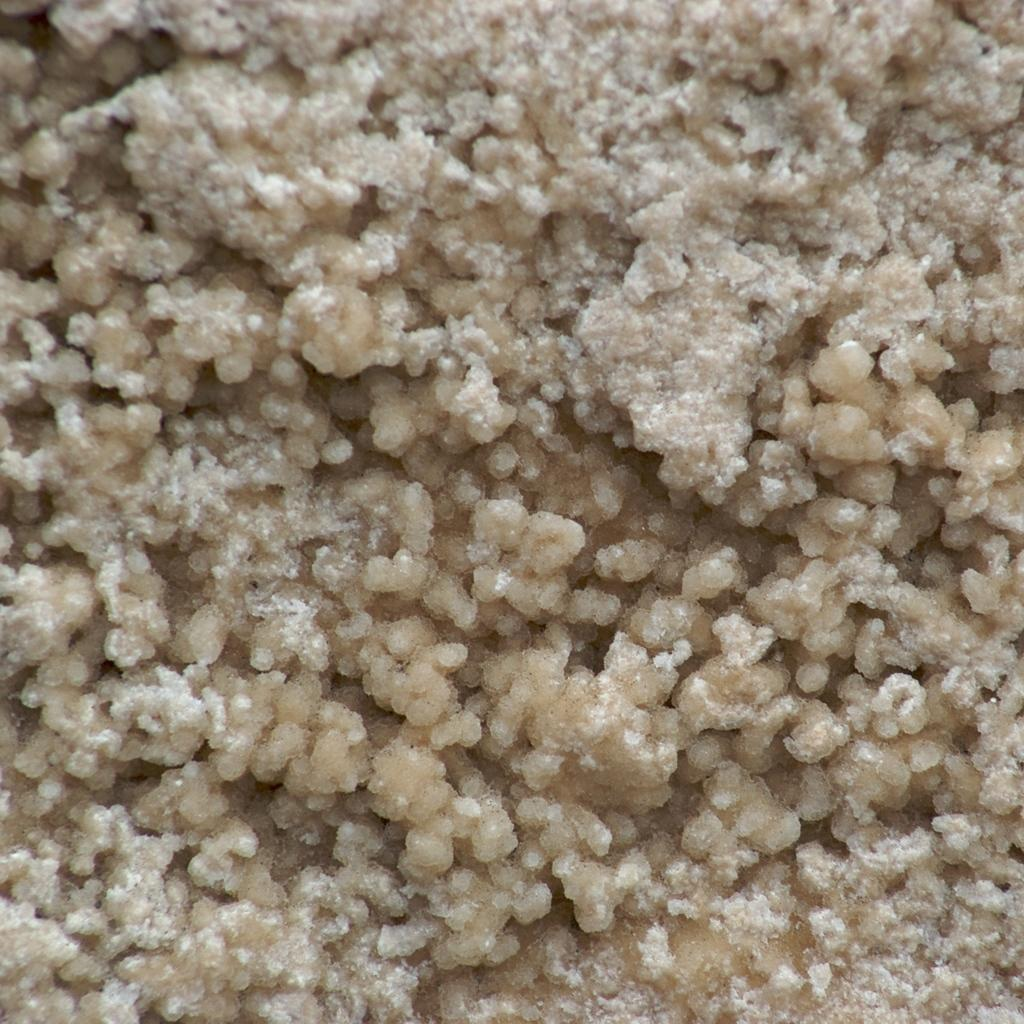What is the main subject of the image? There is a food item in the image. What type of sail can be seen on the food item in the image? There is no sail present on the food item in the image. Is there a crook visible near the food item in the image? There is no crook present in the image. 